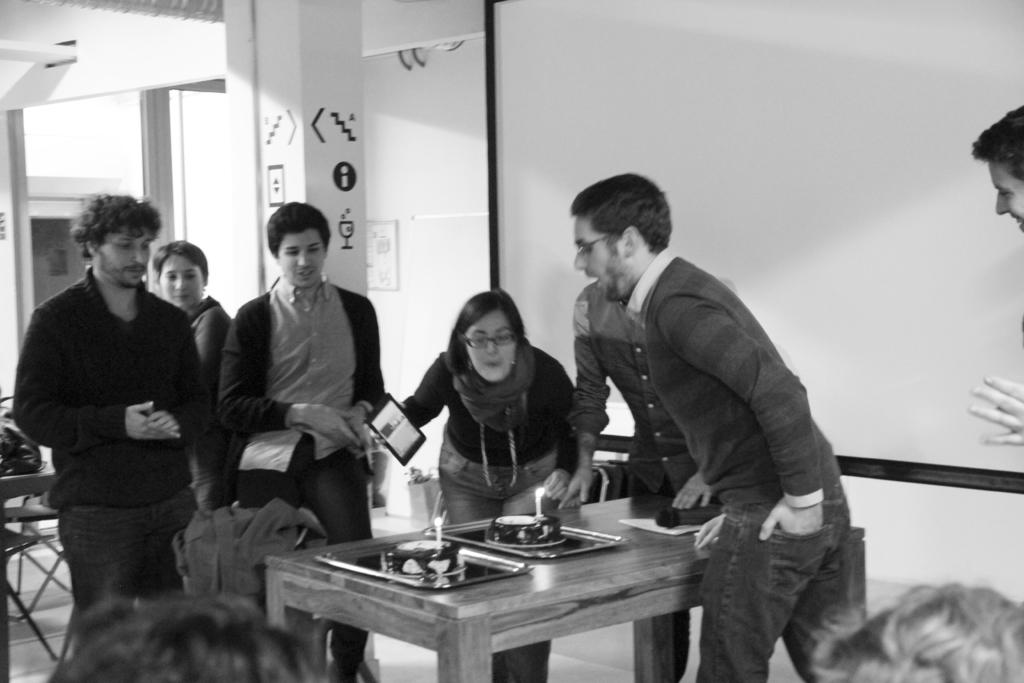How many people are present in the image? There are two people, a man and a woman, present in the image. What are the man and woman doing in the image? Both the man and woman are blowing candles on their birthday cakes. Are there any other people visible in the image? Yes, there are people standing around them. What type of road can be seen in the background of the image? There is no road visible in the image; it features a man and a woman blowing candles on their birthday cakes with people standing around them. 